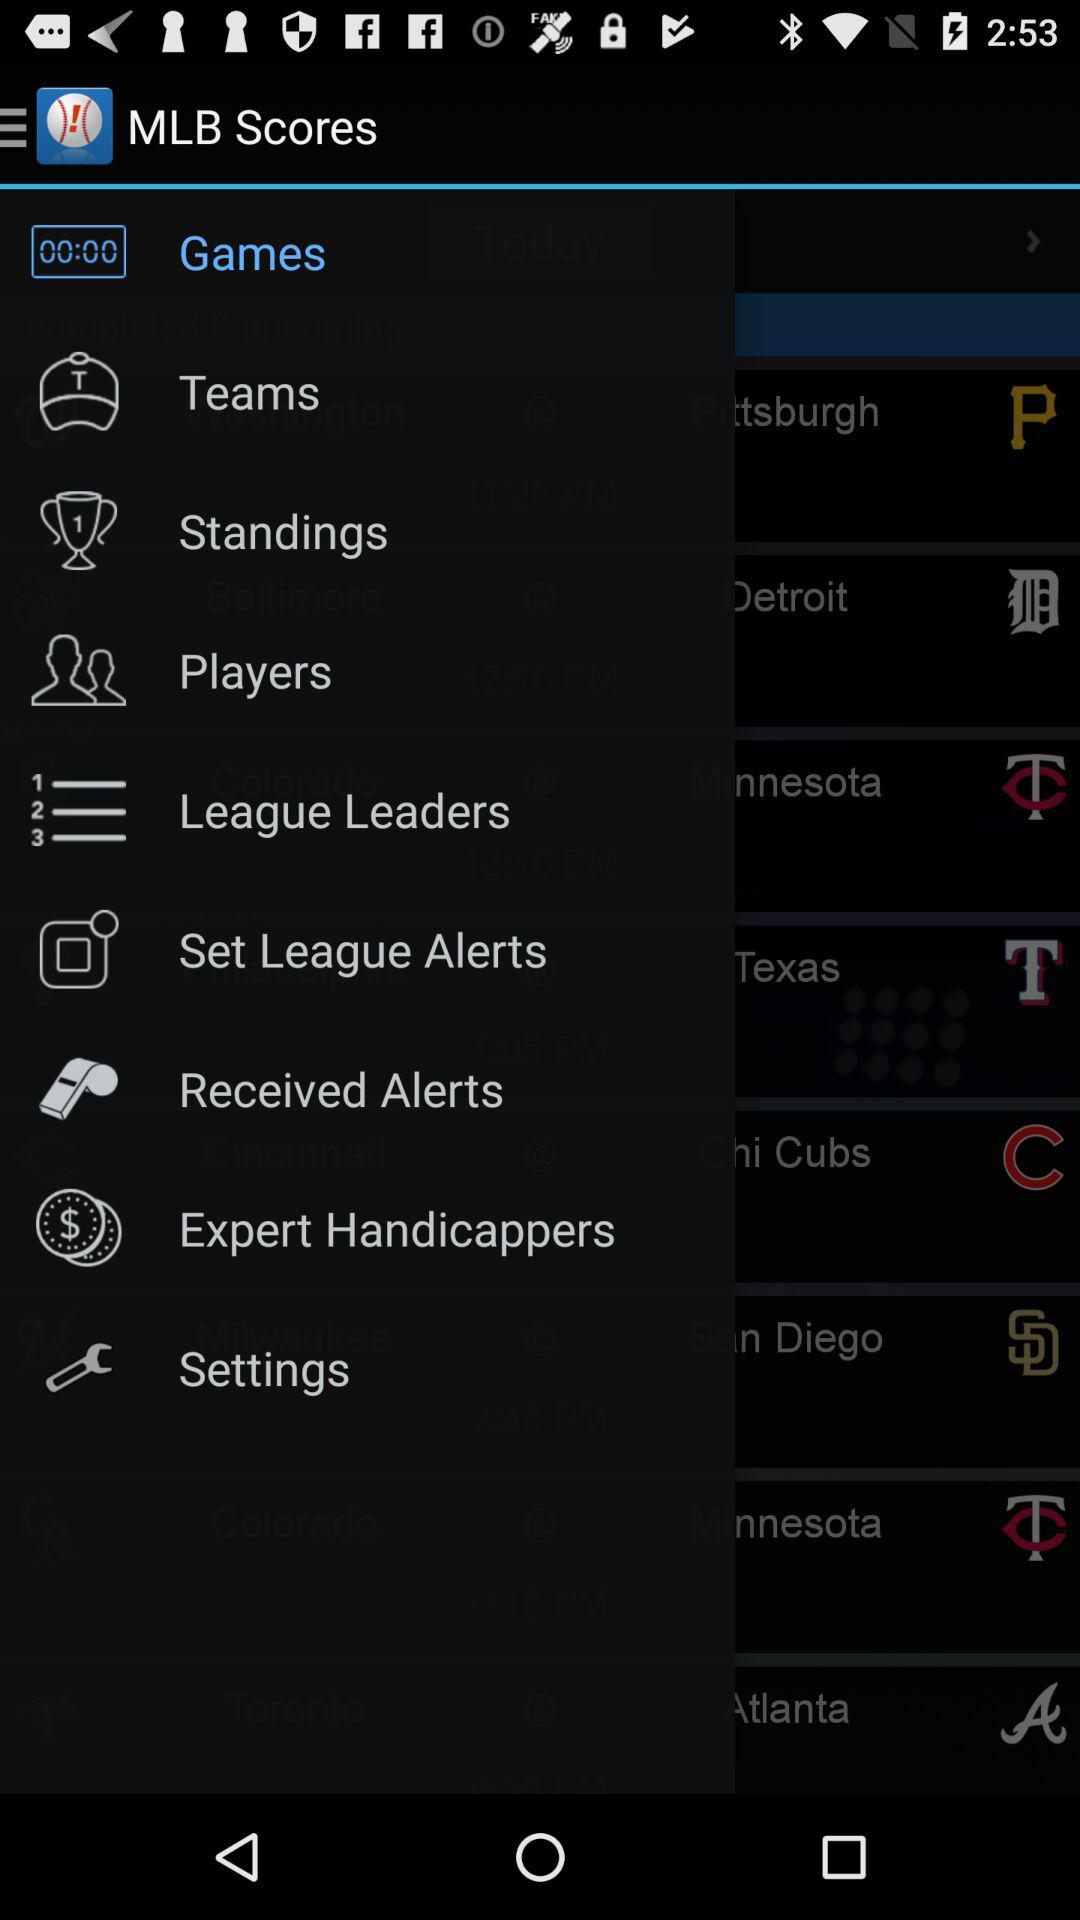What is the name of the application? The name of the application is "MLB Scores". 